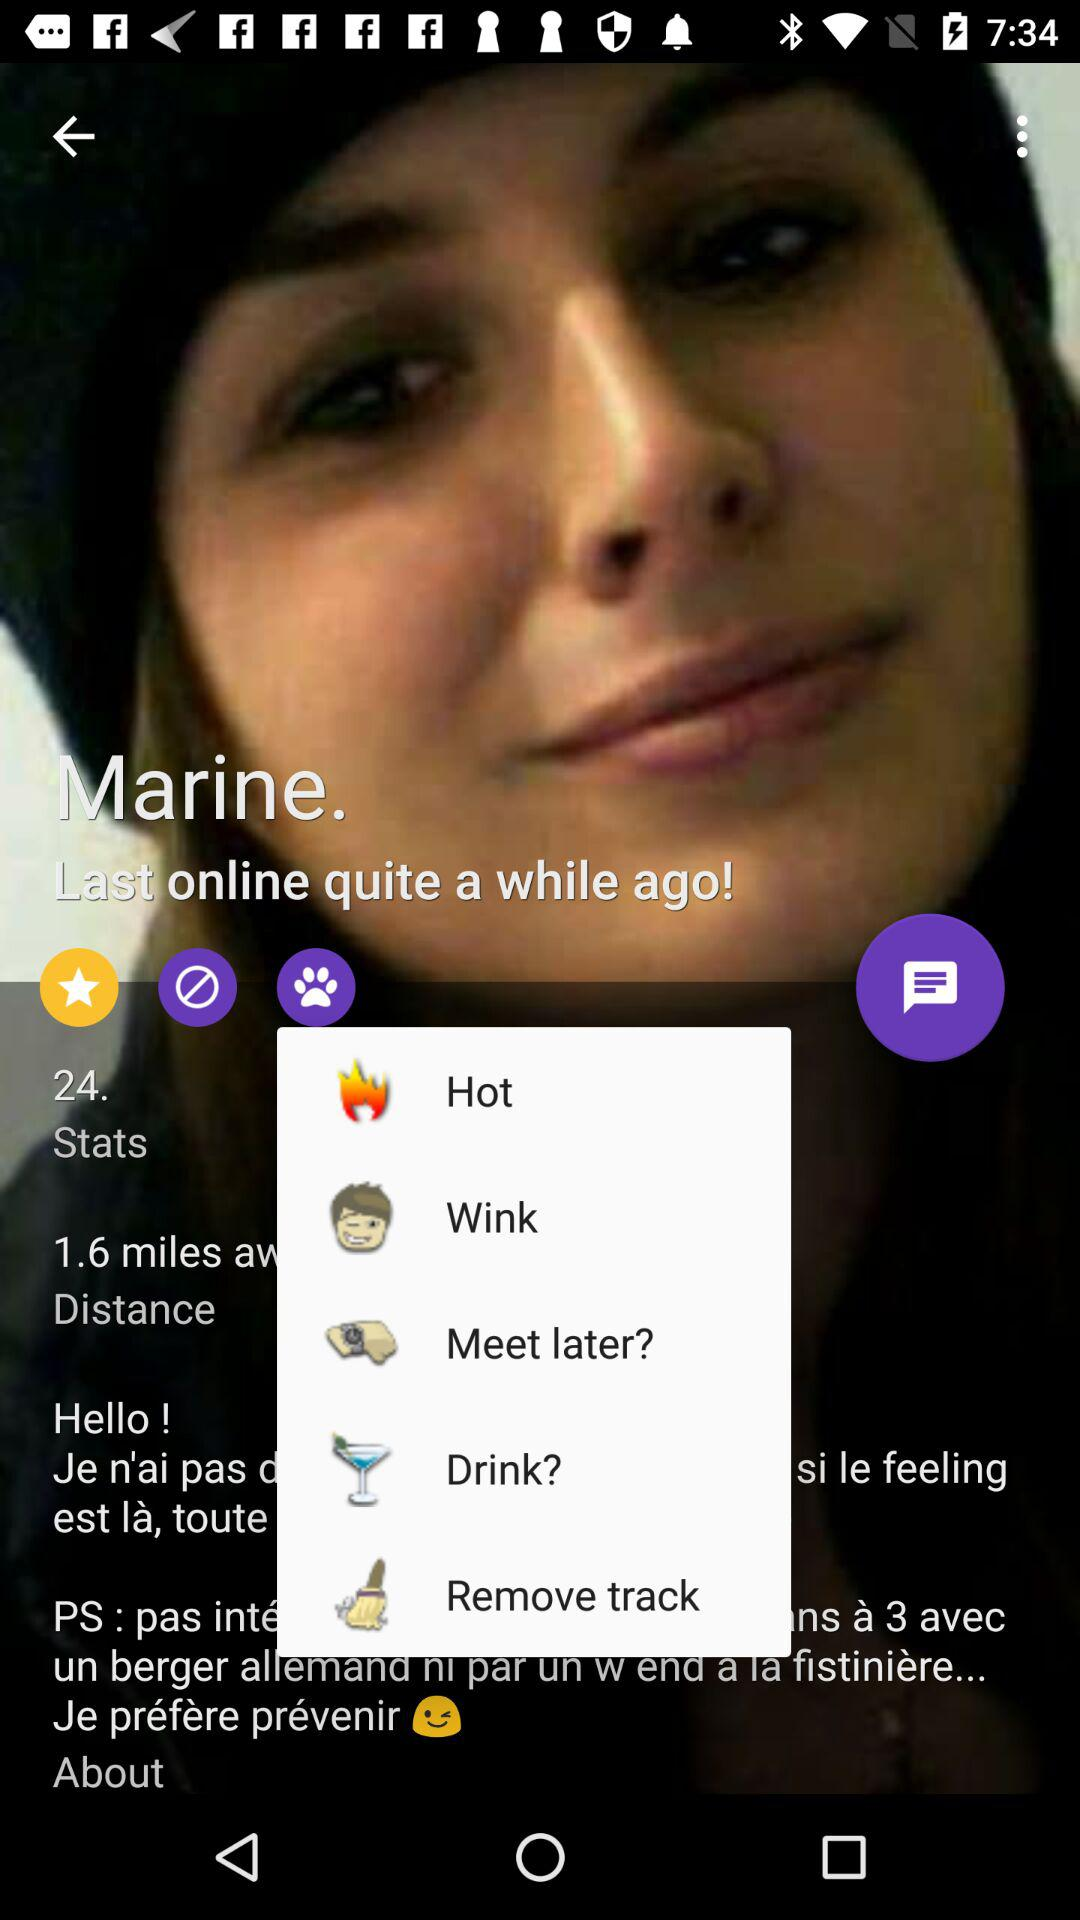What is the name of the user? The name of the user is Marine. 